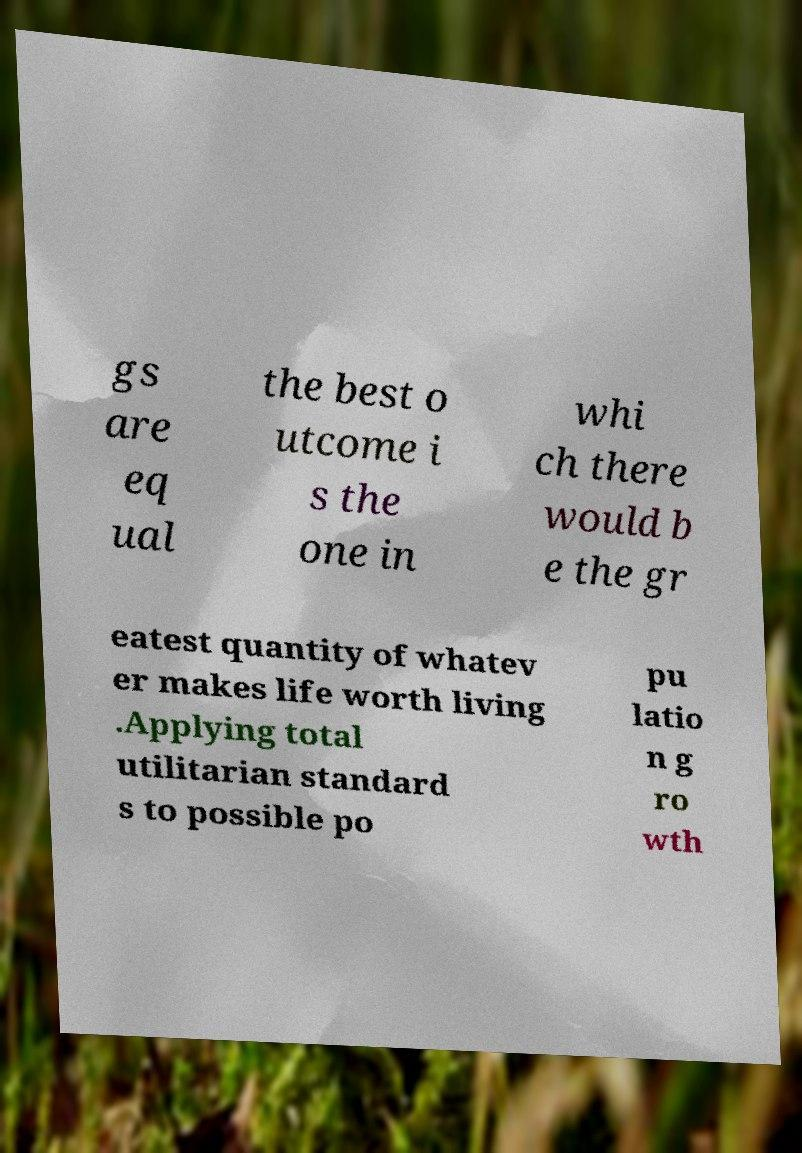Can you accurately transcribe the text from the provided image for me? gs are eq ual the best o utcome i s the one in whi ch there would b e the gr eatest quantity of whatev er makes life worth living .Applying total utilitarian standard s to possible po pu latio n g ro wth 